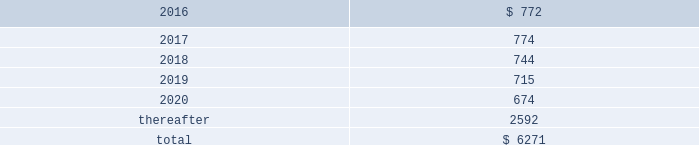Table of contents the company uses some custom components that are not commonly used by its competitors , and new products introduced by the company often utilize custom components available from only one source .
When a component or product uses new technologies , initial capacity constraints may exist until the suppliers 2019 yields have matured or manufacturing capacity has increased .
If the company 2019s supply of components for a new or existing product were delayed or constrained , or if an outsourcing partner delayed shipments of completed products to the company , the company 2019s financial condition and operating results could be materially adversely affected .
The company 2019s business and financial performance could also be materially adversely affected depending on the time required to obtain sufficient quantities from the original source , or to identify and obtain sufficient quantities from an alternative source .
Continued availability of these components at acceptable prices , or at all , may be affected if those suppliers concentrated on the production of common components instead of components customized to meet the company 2019s requirements .
The company has entered into agreements for the supply of many components ; however , there can be no guarantee that the company will be able to extend or renew these agreements on similar terms , or at all .
Therefore , the company remains subject to significant risks of supply shortages and price increases that could materially adversely affect its financial condition and operating results .
Substantially all of the company 2019s hardware products are manufactured by outsourcing partners that are located primarily in asia .
A significant concentration of this manufacturing is currently performed by a small number of outsourcing partners , often in single locations .
Certain of these outsourcing partners are the sole- sourced suppliers of components and manufacturers for many of the company 2019s products .
Although the company works closely with its outsourcing partners on manufacturing schedules , the company 2019s operating results could be adversely affected if its outsourcing partners were unable to meet their production commitments .
The company 2019s purchase commitments typically cover its requirements for periods up to 150 days .
Other off-balance sheet commitments operating leases the company leases various equipment and facilities , including retail space , under noncancelable operating lease arrangements .
The company does not currently utilize any other off-balance sheet financing arrangements .
The major facility leases are typically for terms not exceeding 10 years and generally contain multi-year renewal options .
As of september 26 , 2015 , the company had a total of 463 retail stores .
Leases for retail space are for terms ranging from five to 20 years , the majority of which are for 10 years , and often contain multi-year renewal options .
As of september 26 , 2015 , the company 2019s total future minimum lease payments under noncancelable operating leases were $ 6.3 billion , of which $ 3.6 billion related to leases for retail space .
Rent expense under all operating leases , including both cancelable and noncancelable leases , was $ 794 million , $ 717 million and $ 645 million in 2015 , 2014 and 2013 , respectively .
Future minimum lease payments under noncancelable operating leases having remaining terms in excess of one year as of september 26 , 2015 , are as follows ( in millions ) : .
Other commitments the company utilizes several outsourcing partners to manufacture sub-assemblies for the company 2019s products and to perform final assembly and testing of finished products .
These outsourcing partners acquire components and build product based on demand information supplied by the company , which typically covers periods up to 150 days .
The company also obtains individual components for its products from a wide variety of individual suppliers .
Consistent with industry practice , the company acquires components through a combination of purchase orders , supplier contracts and open orders based on projected demand information .
Where appropriate , the purchases are applied to inventory component prepayments that are outstanding with the respective supplier .
As of september 26 , 2015 , the company had outstanding off-balance sheet third-party manufacturing commitments and component purchase commitments of $ 29.5 billion .
Apple inc .
| 2015 form 10-k | 65 .
For future minimum lease payments under noncancelable operating leases having remaining terms in excess of one year as of september 26 , 2015 , what percentage are due after 5 years? 
Computations: (2592 / 6271)
Answer: 0.41333. 